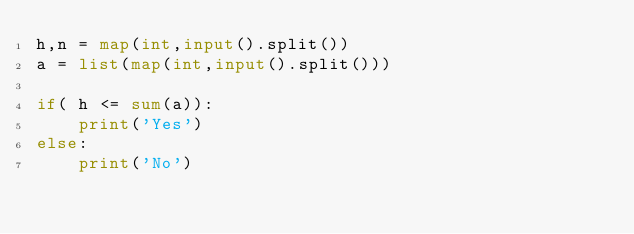Convert code to text. <code><loc_0><loc_0><loc_500><loc_500><_Python_>h,n = map(int,input().split())
a = list(map(int,input().split()))

if( h <= sum(a)):
    print('Yes')
else:
    print('No')</code> 